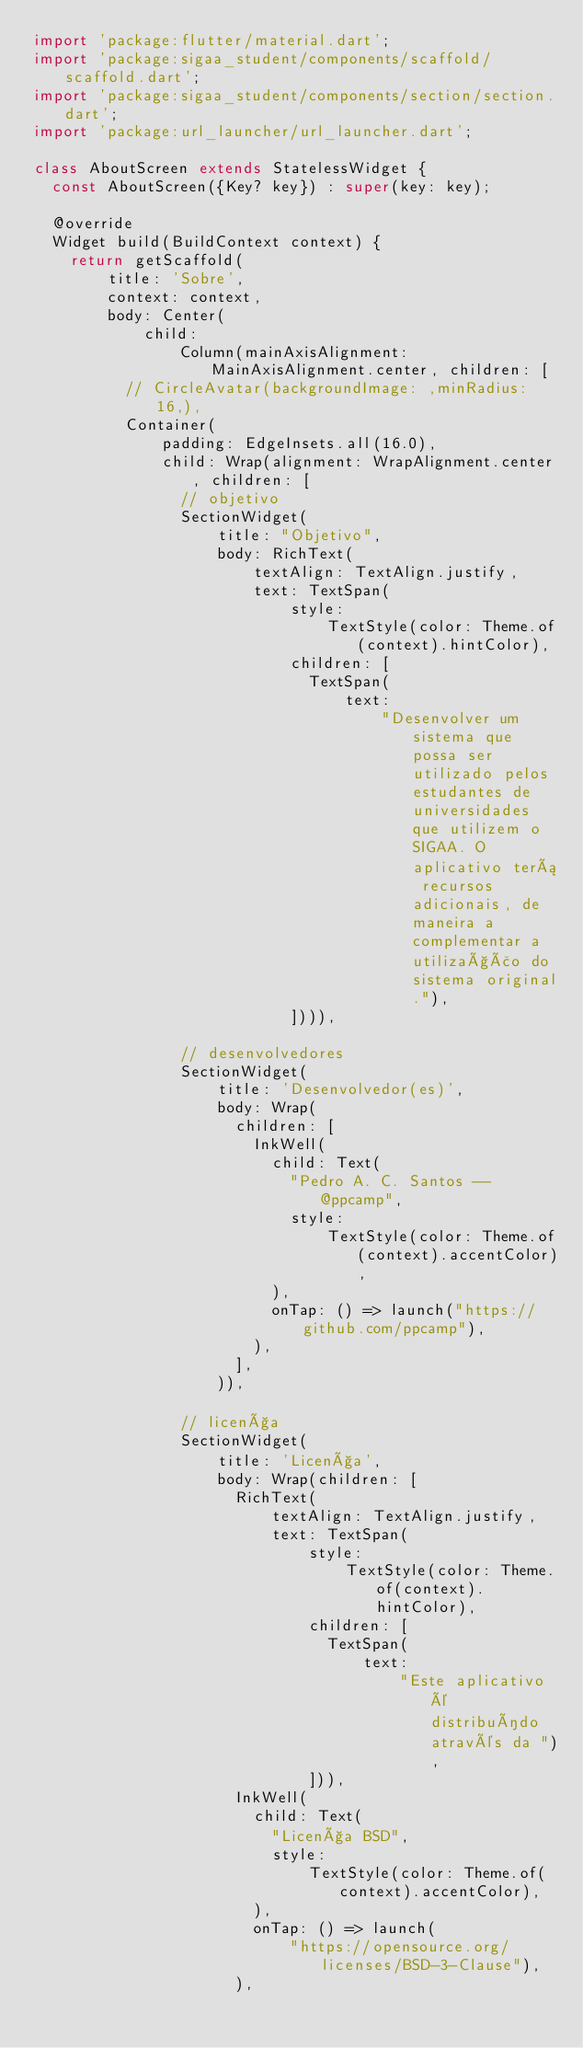<code> <loc_0><loc_0><loc_500><loc_500><_Dart_>import 'package:flutter/material.dart';
import 'package:sigaa_student/components/scaffold/scaffold.dart';
import 'package:sigaa_student/components/section/section.dart';
import 'package:url_launcher/url_launcher.dart';

class AboutScreen extends StatelessWidget {
  const AboutScreen({Key? key}) : super(key: key);

  @override
  Widget build(BuildContext context) {
    return getScaffold(
        title: 'Sobre',
        context: context,
        body: Center(
            child:
                Column(mainAxisAlignment: MainAxisAlignment.center, children: [
          // CircleAvatar(backgroundImage: ,minRadius: 16,),
          Container(
              padding: EdgeInsets.all(16.0),
              child: Wrap(alignment: WrapAlignment.center, children: [
                // objetivo
                SectionWidget(
                    title: "Objetivo",
                    body: RichText(
                        textAlign: TextAlign.justify,
                        text: TextSpan(
                            style:
                                TextStyle(color: Theme.of(context).hintColor),
                            children: [
                              TextSpan(
                                  text:
                                      "Desenvolver um sistema que possa ser utilizado pelos estudantes de universidades que utilizem o SIGAA. O aplicativo terá recursos adicionais, de maneira a complementar a utilização do sistema original."),
                            ]))),

                // desenvolvedores
                SectionWidget(
                    title: 'Desenvolvedor(es)',
                    body: Wrap(
                      children: [
                        InkWell(
                          child: Text(
                            "Pedro A. C. Santos -- @ppcamp",
                            style:
                                TextStyle(color: Theme.of(context).accentColor),
                          ),
                          onTap: () => launch("https://github.com/ppcamp"),
                        ),
                      ],
                    )),

                // licença
                SectionWidget(
                    title: 'Licença',
                    body: Wrap(children: [
                      RichText(
                          textAlign: TextAlign.justify,
                          text: TextSpan(
                              style:
                                  TextStyle(color: Theme.of(context).hintColor),
                              children: [
                                TextSpan(
                                    text:
                                        "Este aplicativo é distribuído através da "),
                              ])),
                      InkWell(
                        child: Text(
                          "Licença BSD",
                          style:
                              TextStyle(color: Theme.of(context).accentColor),
                        ),
                        onTap: () => launch(
                            "https://opensource.org/licenses/BSD-3-Clause"),
                      ),</code> 